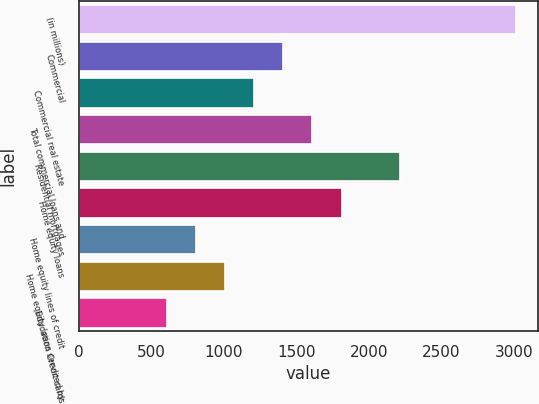Convert chart. <chart><loc_0><loc_0><loc_500><loc_500><bar_chart><fcel>(in millions)<fcel>Commercial<fcel>Commercial real estate<fcel>Total commercial loans and<fcel>Residential mortgages<fcel>Home equity loans<fcel>Home equity lines of credit<fcel>Home equity loans serviced by<fcel>Education Credit cards<nl><fcel>3018.5<fcel>1411.3<fcel>1210.4<fcel>1612.2<fcel>2214.9<fcel>1813.1<fcel>808.6<fcel>1009.5<fcel>607.7<nl></chart> 